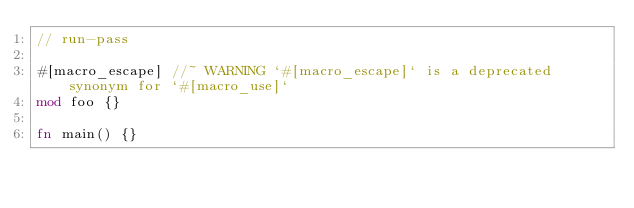<code> <loc_0><loc_0><loc_500><loc_500><_Rust_>// run-pass

#[macro_escape] //~ WARNING `#[macro_escape]` is a deprecated synonym for `#[macro_use]`
mod foo {}

fn main() {}
</code> 